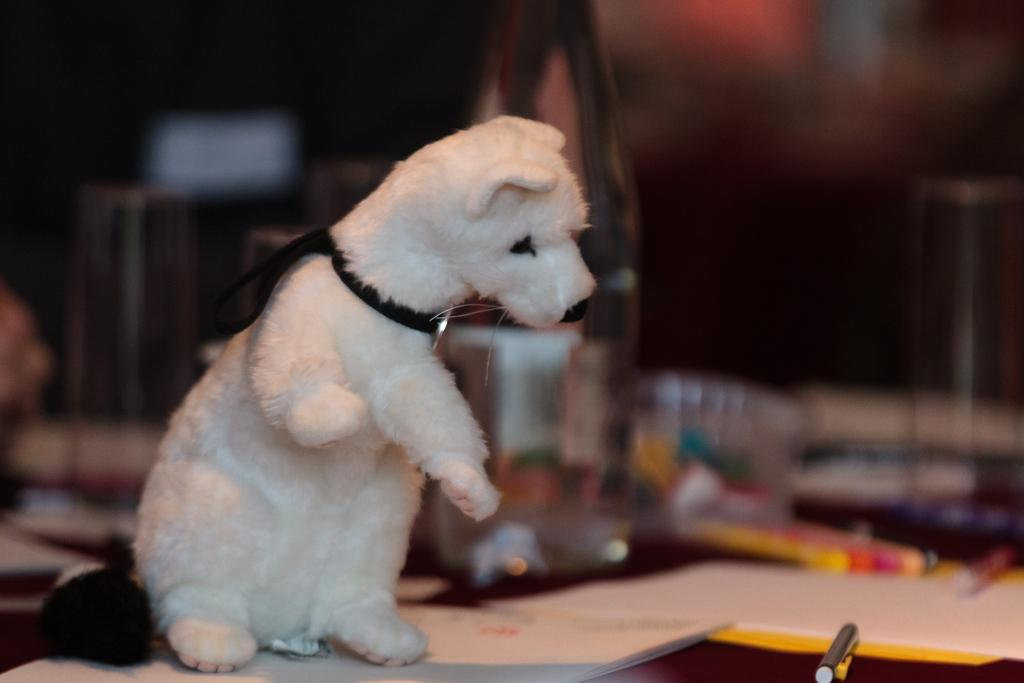What type of animal is in the image? There is a dog in the image, and it is white. What object is on the table in the image? There is a pen on the table. What else is on the table in the image? There are papers on the table. How would you describe the background of the image? The background elements are blurred. What is the opinion of the geese in the image? There are no geese present in the image, so it is not possible to determine their opinion. 